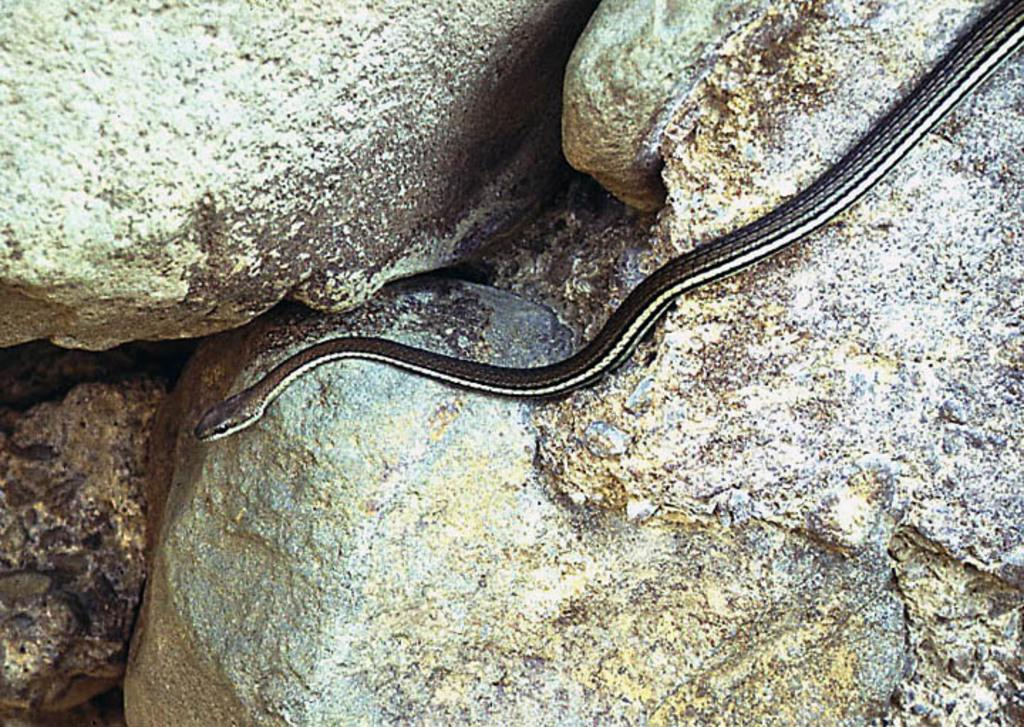What animal is present in the image? There is a snake in the image. What is the snake doing in the image? The snake is crawling on a rock. What type of terrain is visible in the image? There are rocks in the background of the image. What type of bath can be seen in the image? There is no bath present in the image; it features a snake crawling on a rock. What type of secretary is visible in the image? There is no secretary present in the image; it features a snake crawling on a rock. 